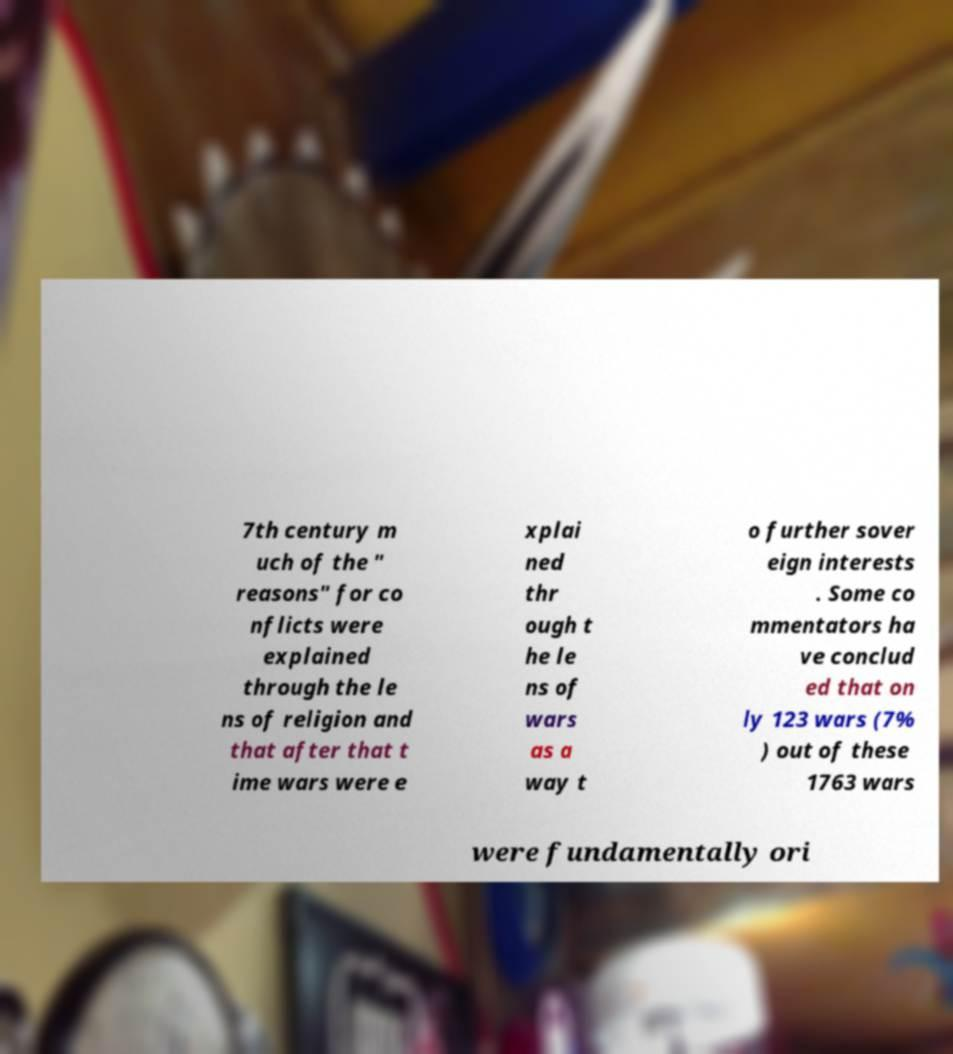Could you extract and type out the text from this image? 7th century m uch of the " reasons" for co nflicts were explained through the le ns of religion and that after that t ime wars were e xplai ned thr ough t he le ns of wars as a way t o further sover eign interests . Some co mmentators ha ve conclud ed that on ly 123 wars (7% ) out of these 1763 wars were fundamentally ori 